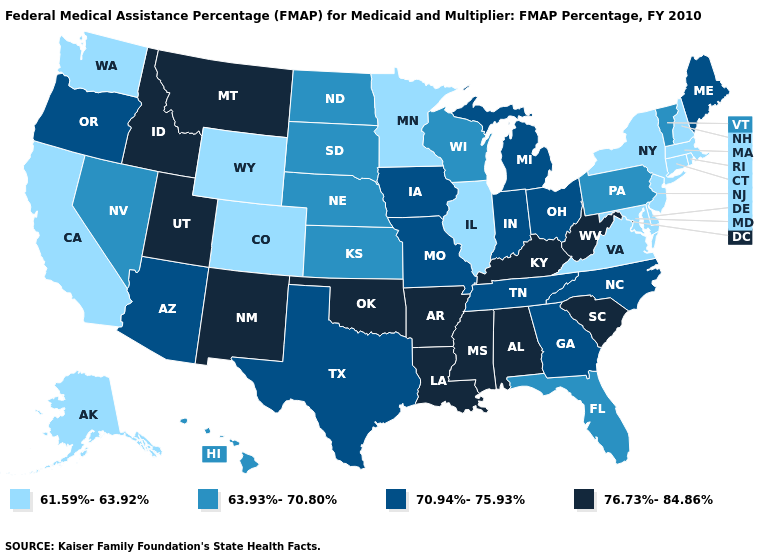Does the first symbol in the legend represent the smallest category?
Write a very short answer. Yes. What is the highest value in the USA?
Give a very brief answer. 76.73%-84.86%. Does Hawaii have the lowest value in the West?
Answer briefly. No. What is the value of North Dakota?
Concise answer only. 63.93%-70.80%. What is the value of Missouri?
Be succinct. 70.94%-75.93%. What is the value of North Carolina?
Short answer required. 70.94%-75.93%. Name the states that have a value in the range 70.94%-75.93%?
Be succinct. Arizona, Georgia, Indiana, Iowa, Maine, Michigan, Missouri, North Carolina, Ohio, Oregon, Tennessee, Texas. Among the states that border Florida , does Alabama have the lowest value?
Write a very short answer. No. What is the highest value in the West ?
Answer briefly. 76.73%-84.86%. Among the states that border Ohio , which have the highest value?
Answer briefly. Kentucky, West Virginia. Does the map have missing data?
Quick response, please. No. What is the value of West Virginia?
Give a very brief answer. 76.73%-84.86%. What is the value of Nevada?
Answer briefly. 63.93%-70.80%. Name the states that have a value in the range 63.93%-70.80%?
Answer briefly. Florida, Hawaii, Kansas, Nebraska, Nevada, North Dakota, Pennsylvania, South Dakota, Vermont, Wisconsin. What is the value of Arizona?
Answer briefly. 70.94%-75.93%. 